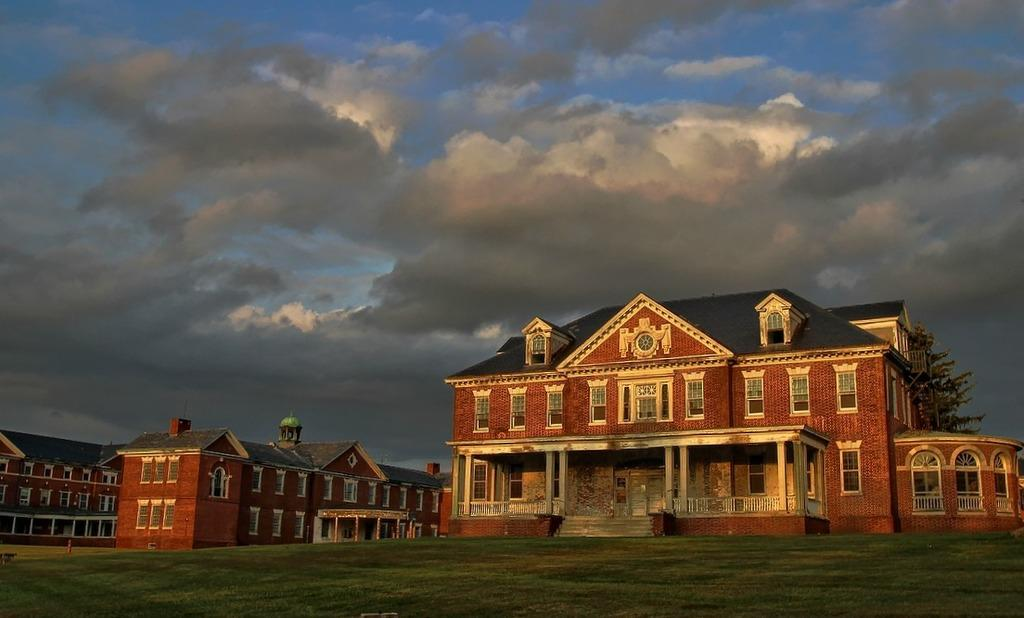What type of surface can be seen in the image? The ground is visible in the image. What is covering the ground? There is grass on the ground. What colors are the buildings in the image? The buildings in the image are brown, cream, and black. What can be seen in the background of the image? There are trees and the sky visible in the background of the image. Can you hear the aunt talking to the waves in the image? There is no aunt or waves present in the image, so it is not possible to hear any conversation or interaction with waves. 